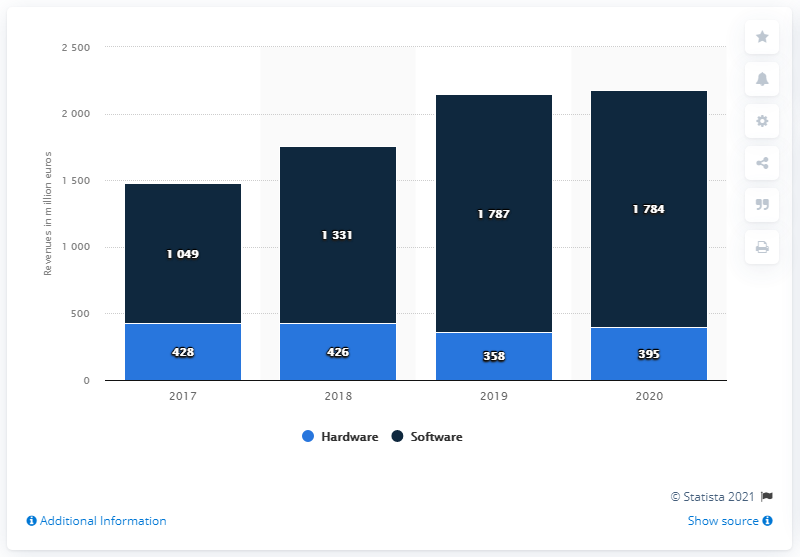Outline some significant characteristics in this image. In Italy in 2020, hardware sales generated a total of approximately 395 million euros. In Italy, the combined sales of physical and digital games in 2020 totaled 1784. 